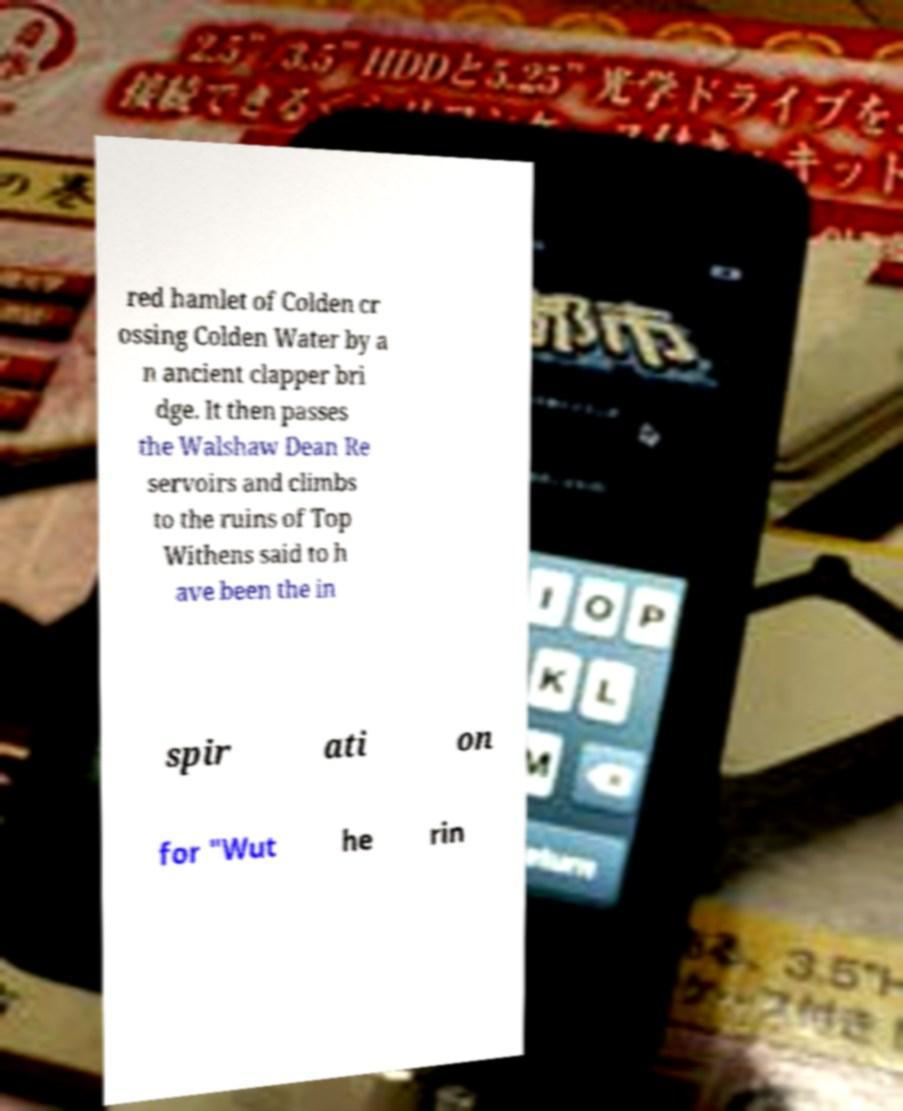Can you accurately transcribe the text from the provided image for me? red hamlet of Colden cr ossing Colden Water by a n ancient clapper bri dge. It then passes the Walshaw Dean Re servoirs and climbs to the ruins of Top Withens said to h ave been the in spir ati on for "Wut he rin 